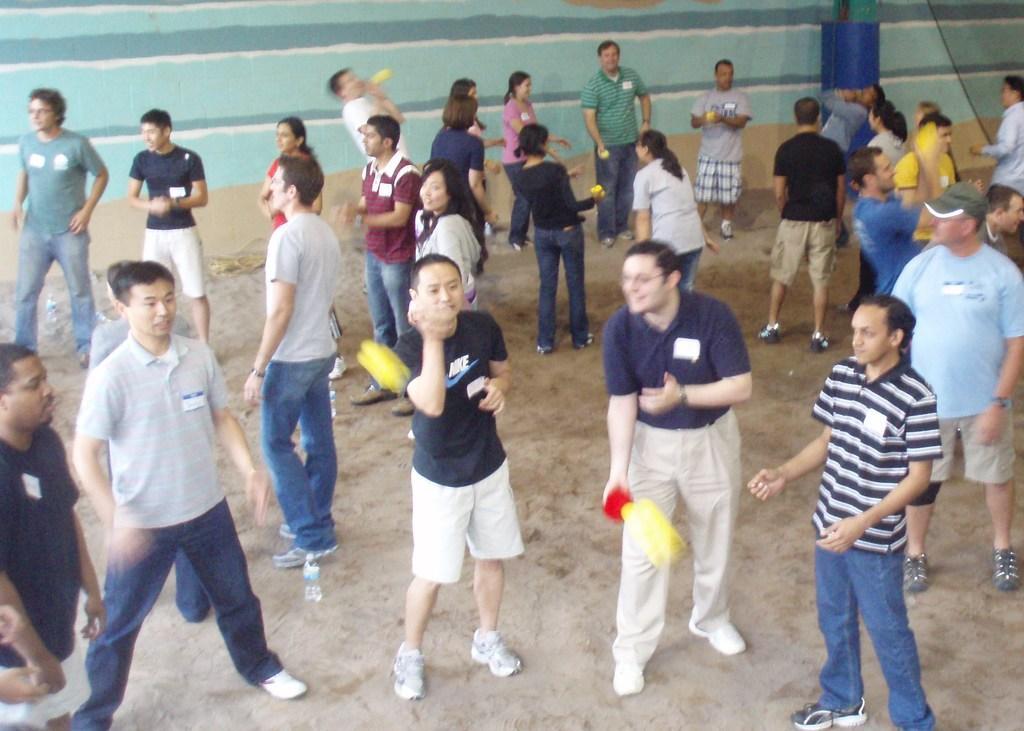Describe this image in one or two sentences. In this image in the center there are persons standing and playing. In the background there is a wall which is green in colour and in front of the wall there is a wire. 